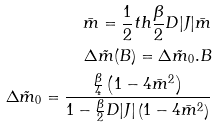Convert formula to latex. <formula><loc_0><loc_0><loc_500><loc_500>\bar { m } = \frac { 1 } { 2 } t h \frac { \beta } { 2 } D | J | \bar { m } \\ \Delta \tilde { m } ( B ) = \Delta \tilde { m } _ { 0 } . B \\ \Delta \tilde { m } _ { 0 } = \frac { \frac { \beta } { 4 } \left ( 1 - 4 \bar { m } ^ { 2 } \right ) } { 1 - \frac { \beta } { 2 } D | J | \left ( 1 - 4 \bar { m } ^ { 2 } \right ) }</formula> 